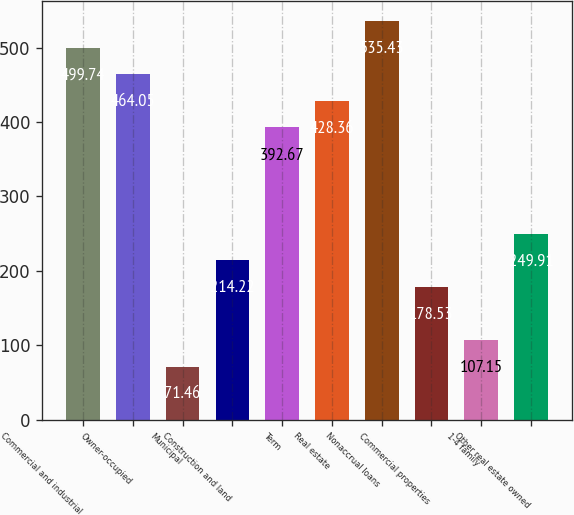<chart> <loc_0><loc_0><loc_500><loc_500><bar_chart><fcel>Commercial and industrial<fcel>Owner-occupied<fcel>Municipal<fcel>Construction and land<fcel>Term<fcel>Real estate<fcel>Nonaccrual loans<fcel>Commercial properties<fcel>1-4 family<fcel>Other real estate owned<nl><fcel>499.74<fcel>464.05<fcel>71.46<fcel>214.22<fcel>392.67<fcel>428.36<fcel>535.43<fcel>178.53<fcel>107.15<fcel>249.91<nl></chart> 